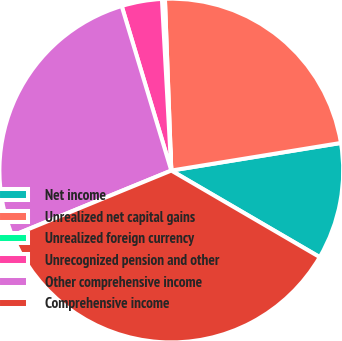Convert chart to OTSL. <chart><loc_0><loc_0><loc_500><loc_500><pie_chart><fcel>Net income<fcel>Unrealized net capital gains<fcel>Unrealized foreign currency<fcel>Unrecognized pension and other<fcel>Other comprehensive income<fcel>Comprehensive income<nl><fcel>10.97%<fcel>23.02%<fcel>0.28%<fcel>3.79%<fcel>26.53%<fcel>35.4%<nl></chart> 